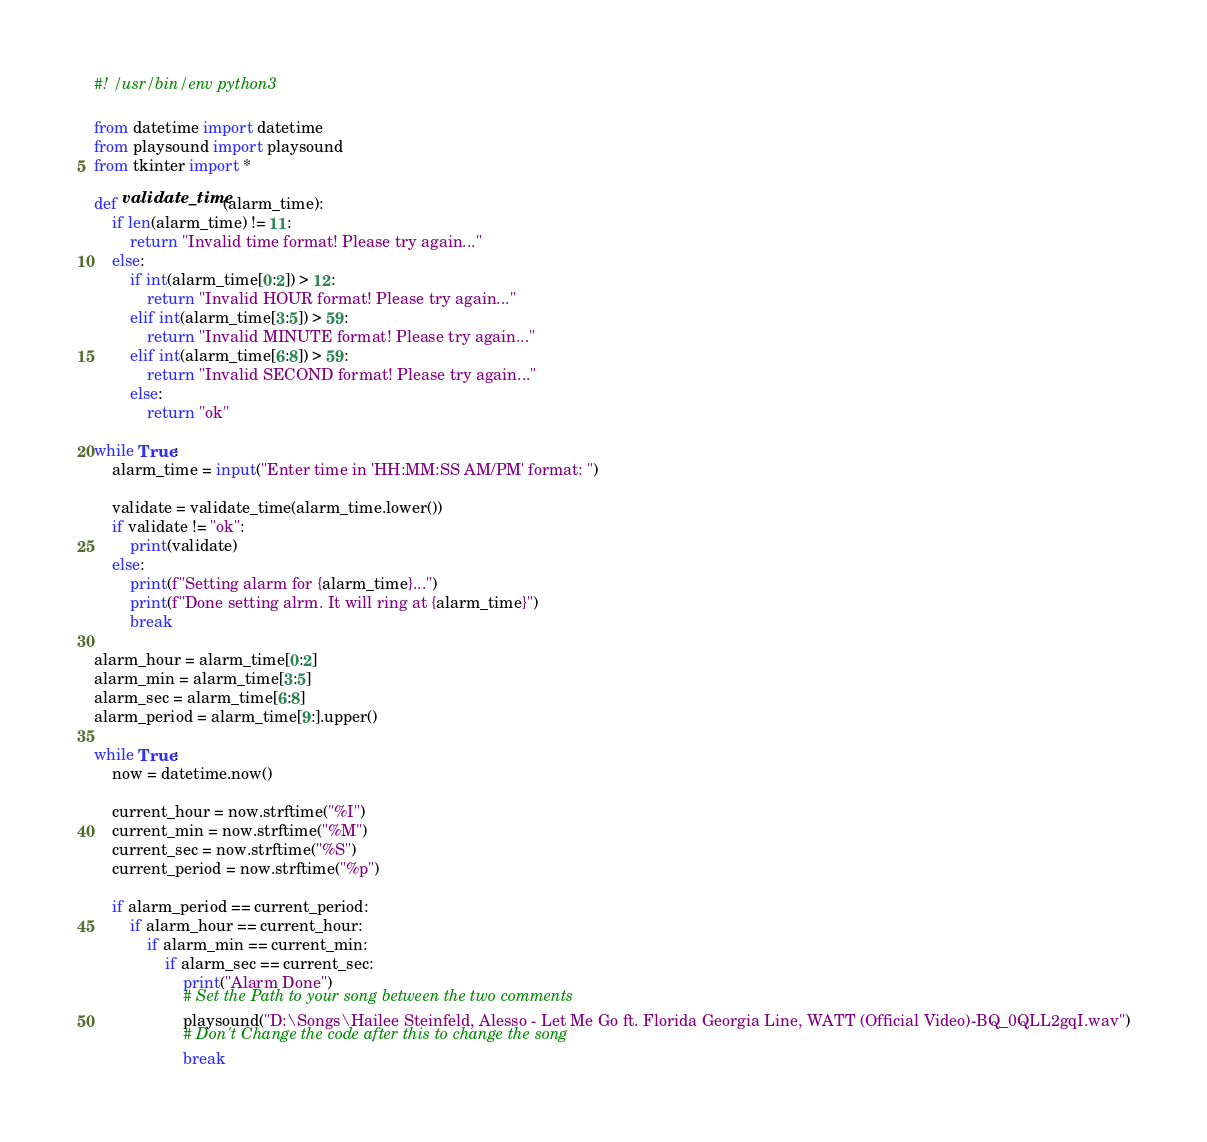<code> <loc_0><loc_0><loc_500><loc_500><_Python_>#! /usr/bin/env python3

from datetime import datetime   
from playsound import playsound
from tkinter import *

def validate_time(alarm_time):
    if len(alarm_time) != 11:
        return "Invalid time format! Please try again..."
    else:
        if int(alarm_time[0:2]) > 12:
            return "Invalid HOUR format! Please try again..."
        elif int(alarm_time[3:5]) > 59:
            return "Invalid MINUTE format! Please try again..."
        elif int(alarm_time[6:8]) > 59:
            return "Invalid SECOND format! Please try again..."
        else:
            return "ok"

while True:
    alarm_time = input("Enter time in 'HH:MM:SS AM/PM' format: ")
    
    validate = validate_time(alarm_time.lower())
    if validate != "ok":
        print(validate)
    else:
        print(f"Setting alarm for {alarm_time}...")
        print(f"Done setting alrm. It will ring at {alarm_time}")
        break
    
alarm_hour = alarm_time[0:2]
alarm_min = alarm_time[3:5]
alarm_sec = alarm_time[6:8]
alarm_period = alarm_time[9:].upper()

while True:
    now = datetime.now()

    current_hour = now.strftime("%I")
    current_min = now.strftime("%M")
    current_sec = now.strftime("%S")
    current_period = now.strftime("%p")

    if alarm_period == current_period:
        if alarm_hour == current_hour:
            if alarm_min == current_min:
                if alarm_sec == current_sec:
                    print("Alarm Done")
                    # Set the Path to your song between the two comments
                    playsound("D:\Songs\Hailee Steinfeld, Alesso - Let Me Go ft. Florida Georgia Line, WATT (Official Video)-BQ_0QLL2gqI.wav")
                    # Don't Change the code after this to change the song
                    break
</code> 